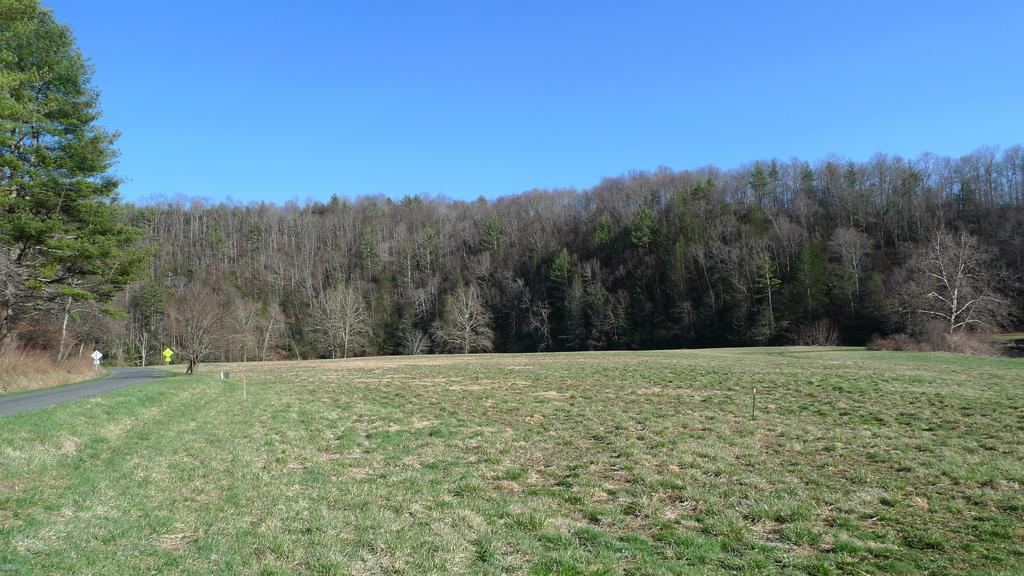What type of surface is visible in the image? There is grass on the surface in the image. What can be seen on the left side of the image? There is a road on the left side of the image. What are the sign boards near the road used for? The sign boards near the road provide information or directions. What type of vegetation is visible at the back side of the image? There are trees visible at the back side of the image. What is visible at the top of the image? The sky is visible at the top of the image. What type of whip can be seen in the mouth of the thing in the image? There is no whip or thing present in the image. 